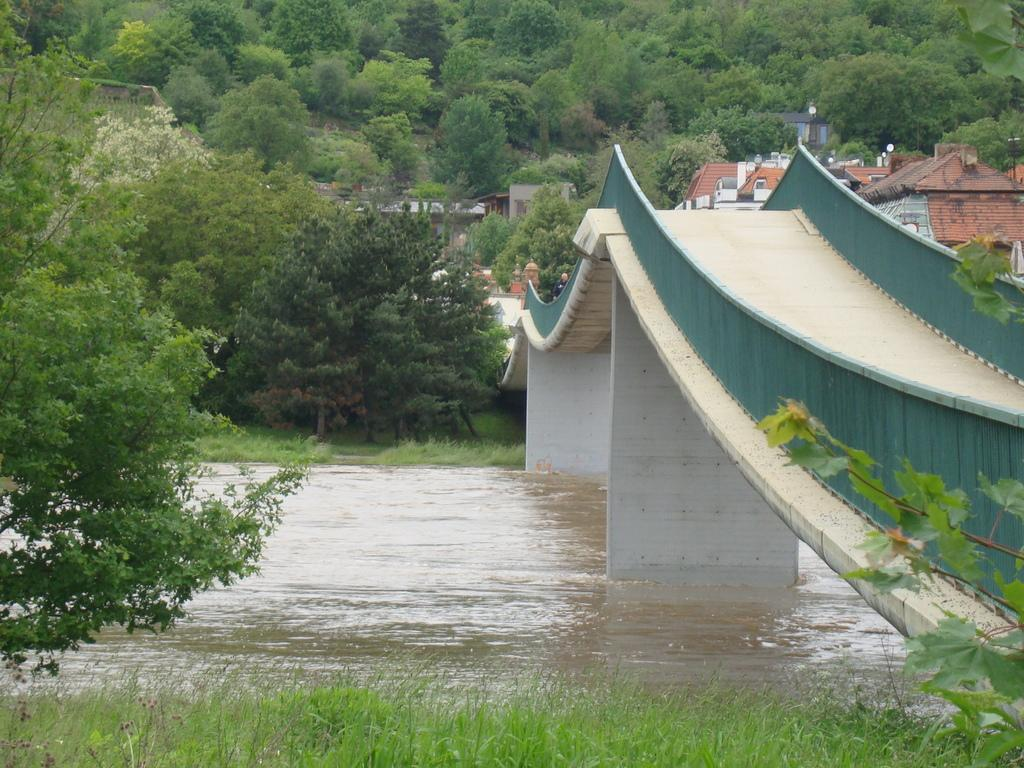What type of structure is present in the image? There is a bridge with pillars in the image. What else can be seen in the image besides the bridge? There are buildings, trees, and a river in the image. Are there any plants visible in the image? Yes, there are plants on the sides of the river and trees in the background of the image. How much wealth is depicted in the image? The image does not depict wealth; it shows a bridge, buildings, trees, and a river. What type of picture is being displayed in the image? There is no picture being displayed in the image; it is a scene of a bridge, buildings, trees, and a river. 